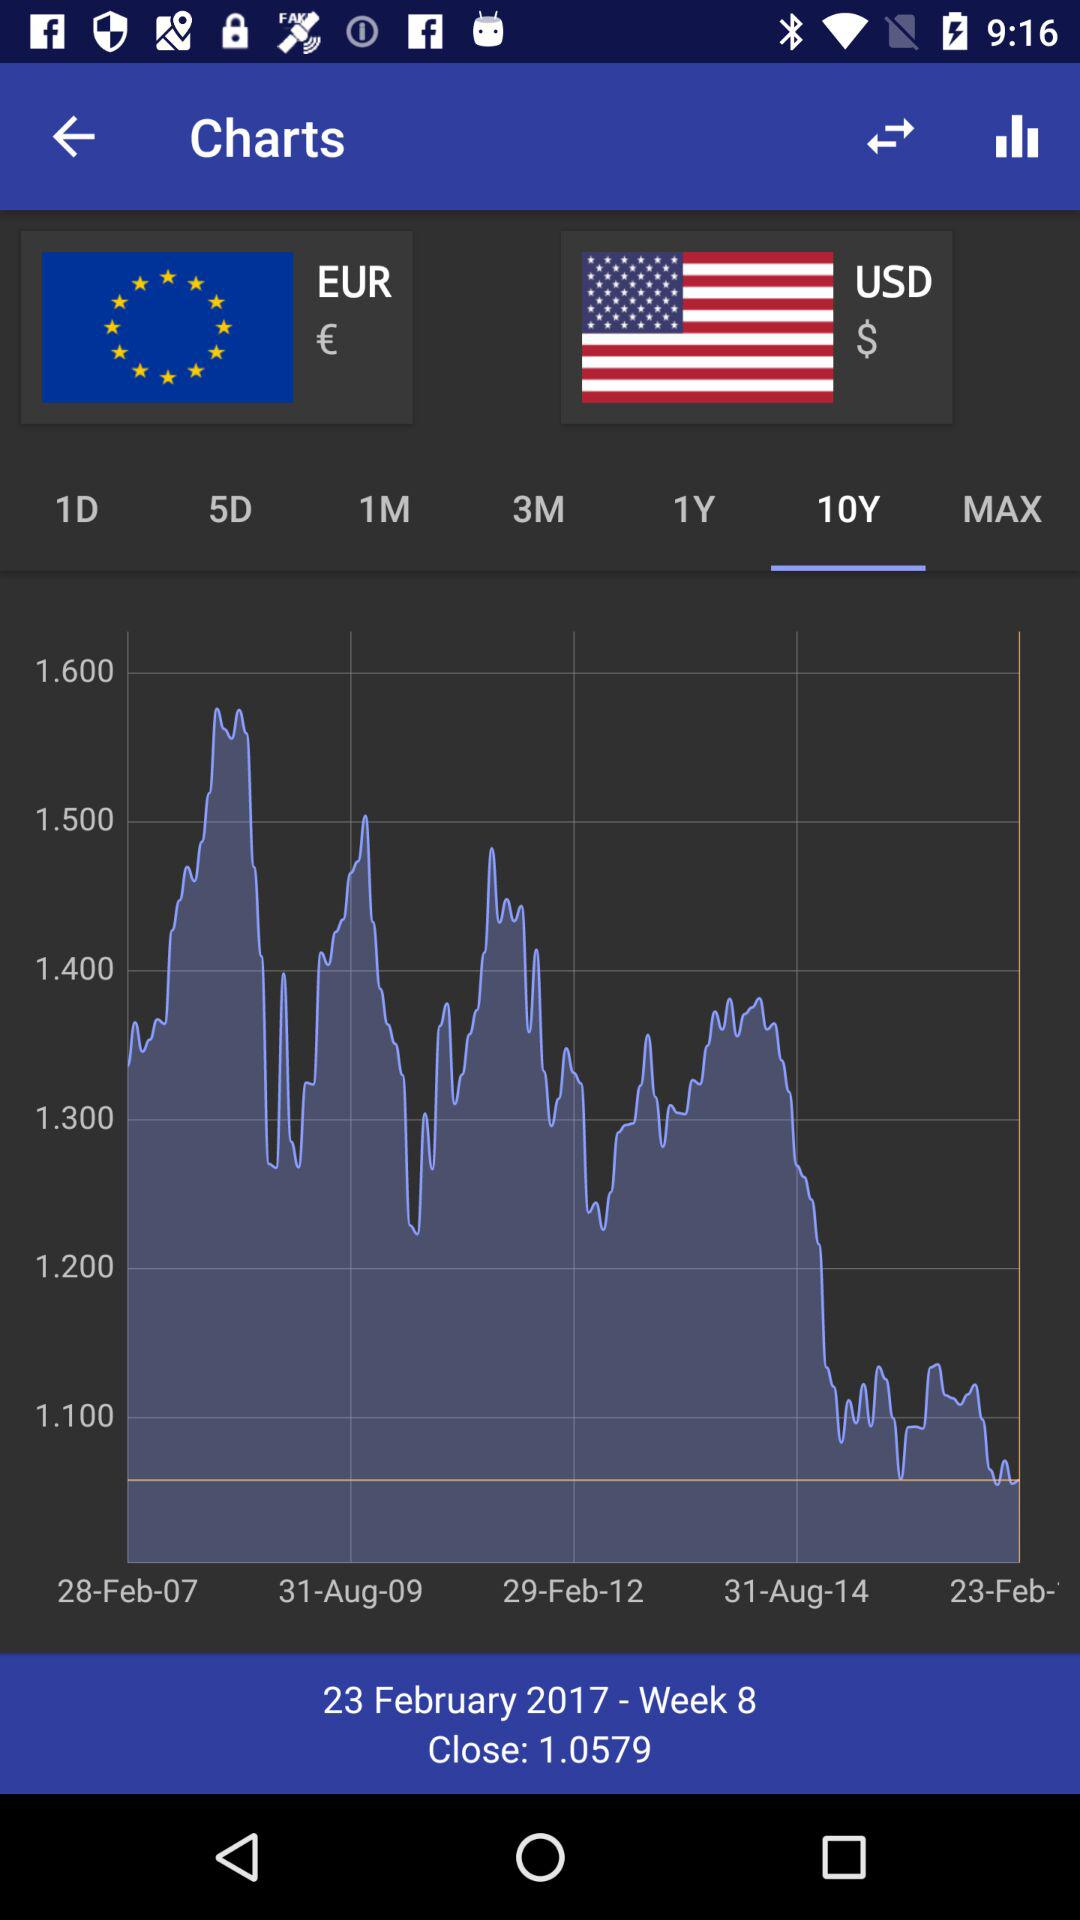What is the close price of the EUR/USD exchange rate?
Answer the question using a single word or phrase. 1.0579 